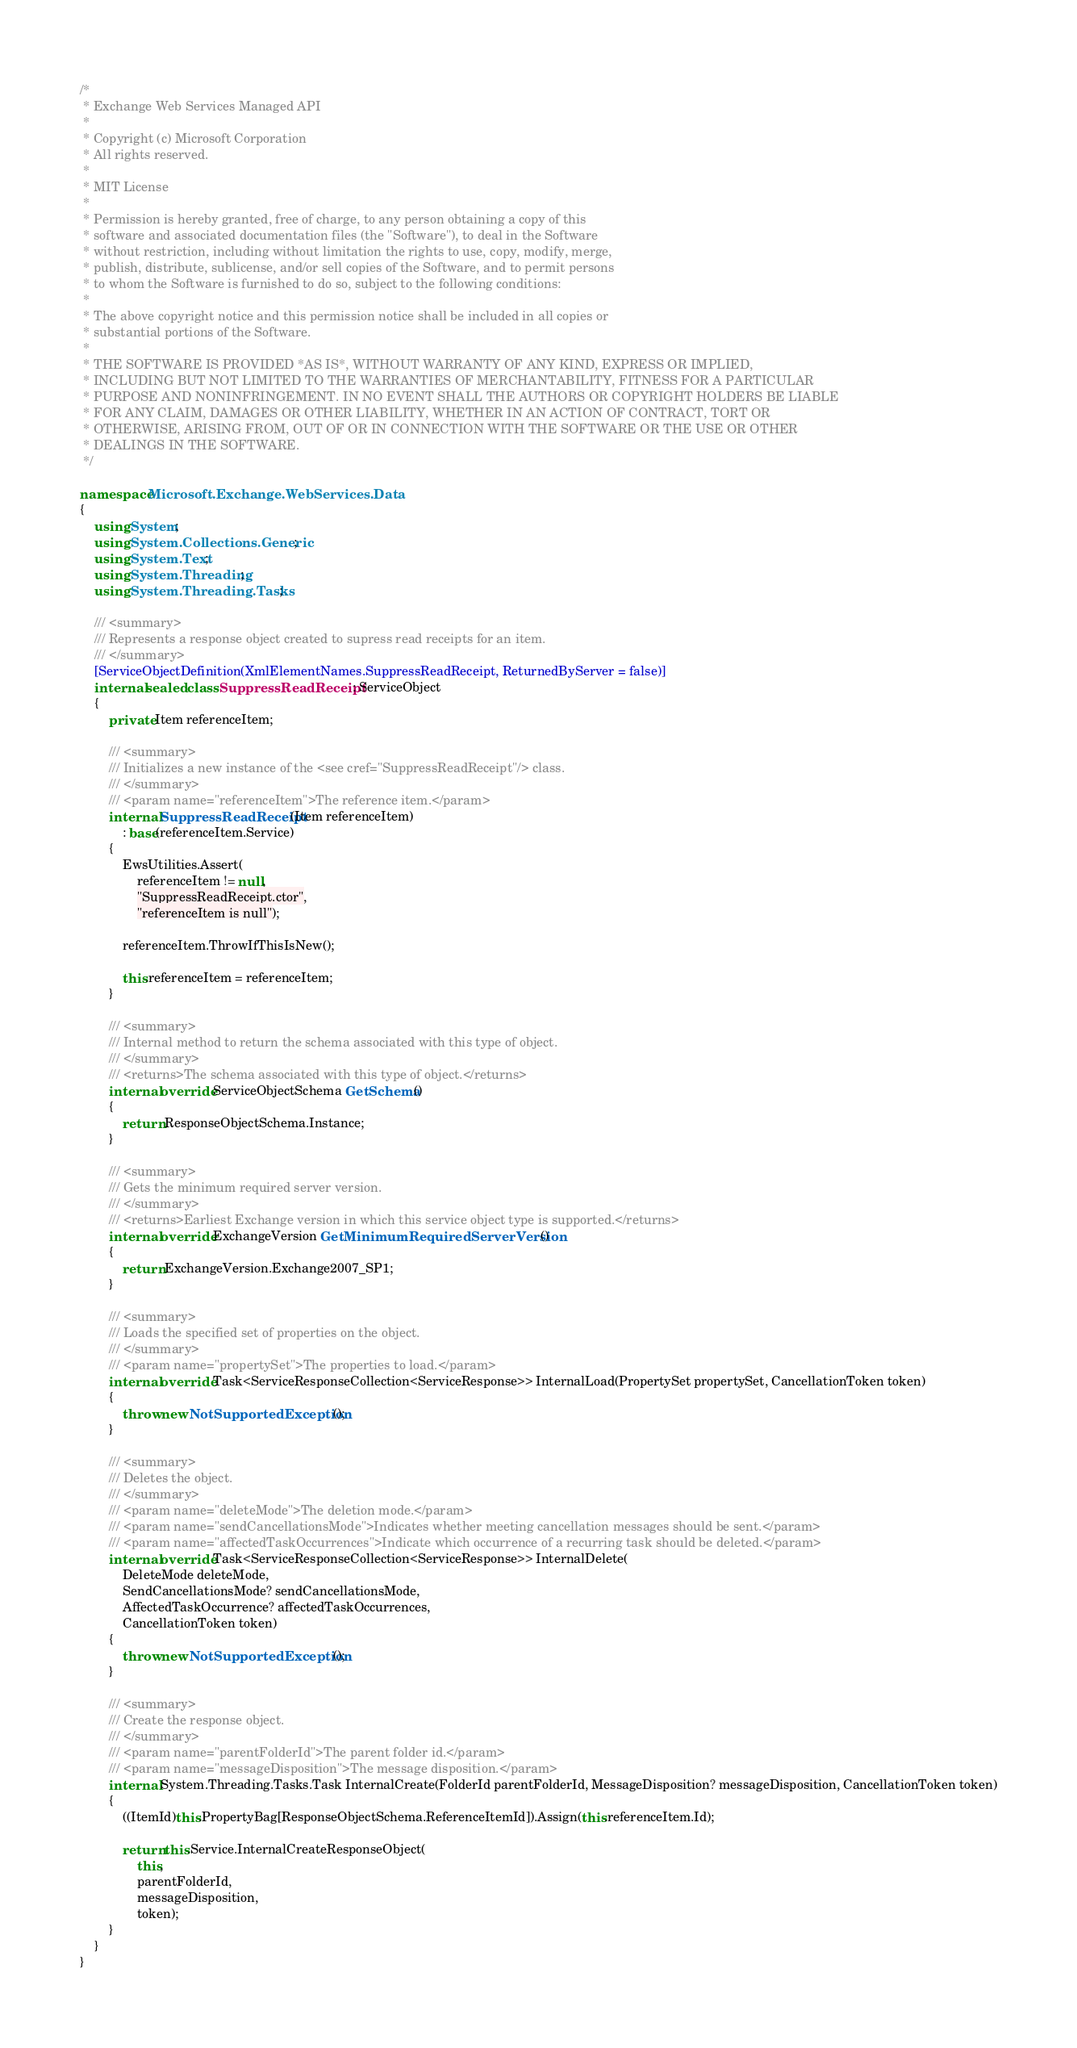<code> <loc_0><loc_0><loc_500><loc_500><_C#_>/*
 * Exchange Web Services Managed API
 *
 * Copyright (c) Microsoft Corporation
 * All rights reserved.
 *
 * MIT License
 *
 * Permission is hereby granted, free of charge, to any person obtaining a copy of this
 * software and associated documentation files (the "Software"), to deal in the Software
 * without restriction, including without limitation the rights to use, copy, modify, merge,
 * publish, distribute, sublicense, and/or sell copies of the Software, and to permit persons
 * to whom the Software is furnished to do so, subject to the following conditions:
 *
 * The above copyright notice and this permission notice shall be included in all copies or
 * substantial portions of the Software.
 *
 * THE SOFTWARE IS PROVIDED *AS IS*, WITHOUT WARRANTY OF ANY KIND, EXPRESS OR IMPLIED,
 * INCLUDING BUT NOT LIMITED TO THE WARRANTIES OF MERCHANTABILITY, FITNESS FOR A PARTICULAR
 * PURPOSE AND NONINFRINGEMENT. IN NO EVENT SHALL THE AUTHORS OR COPYRIGHT HOLDERS BE LIABLE
 * FOR ANY CLAIM, DAMAGES OR OTHER LIABILITY, WHETHER IN AN ACTION OF CONTRACT, TORT OR
 * OTHERWISE, ARISING FROM, OUT OF OR IN CONNECTION WITH THE SOFTWARE OR THE USE OR OTHER
 * DEALINGS IN THE SOFTWARE.
 */

namespace Microsoft.Exchange.WebServices.Data
{
    using System;
    using System.Collections.Generic;
    using System.Text;
    using System.Threading;
    using System.Threading.Tasks;

    /// <summary>
    /// Represents a response object created to supress read receipts for an item.
    /// </summary>
    [ServiceObjectDefinition(XmlElementNames.SuppressReadReceipt, ReturnedByServer = false)]
    internal sealed class SuppressReadReceipt : ServiceObject
    {
        private Item referenceItem;

        /// <summary>
        /// Initializes a new instance of the <see cref="SuppressReadReceipt"/> class.
        /// </summary>
        /// <param name="referenceItem">The reference item.</param>
        internal SuppressReadReceipt(Item referenceItem)
            : base(referenceItem.Service)
        {
            EwsUtilities.Assert(
                referenceItem != null,
                "SuppressReadReceipt.ctor",
                "referenceItem is null");

            referenceItem.ThrowIfThisIsNew();

            this.referenceItem = referenceItem;
        }

        /// <summary>
        /// Internal method to return the schema associated with this type of object.
        /// </summary>
        /// <returns>The schema associated with this type of object.</returns>
        internal override ServiceObjectSchema GetSchema()
        {
            return ResponseObjectSchema.Instance;
        }

        /// <summary>
        /// Gets the minimum required server version.
        /// </summary>
        /// <returns>Earliest Exchange version in which this service object type is supported.</returns>
        internal override ExchangeVersion GetMinimumRequiredServerVersion()
        {
            return ExchangeVersion.Exchange2007_SP1;
        }

        /// <summary>
        /// Loads the specified set of properties on the object.
        /// </summary>
        /// <param name="propertySet">The properties to load.</param>
        internal override Task<ServiceResponseCollection<ServiceResponse>> InternalLoad(PropertySet propertySet, CancellationToken token)
        {
            throw new NotSupportedException();
        }

        /// <summary>
        /// Deletes the object.
        /// </summary>
        /// <param name="deleteMode">The deletion mode.</param>
        /// <param name="sendCancellationsMode">Indicates whether meeting cancellation messages should be sent.</param>
        /// <param name="affectedTaskOccurrences">Indicate which occurrence of a recurring task should be deleted.</param>
        internal override Task<ServiceResponseCollection<ServiceResponse>> InternalDelete(
            DeleteMode deleteMode,
            SendCancellationsMode? sendCancellationsMode,
            AffectedTaskOccurrence? affectedTaskOccurrences,
            CancellationToken token)
        {
            throw new NotSupportedException();
        }

        /// <summary>
        /// Create the response object.
        /// </summary>
        /// <param name="parentFolderId">The parent folder id.</param>
        /// <param name="messageDisposition">The message disposition.</param>
        internal System.Threading.Tasks.Task InternalCreate(FolderId parentFolderId, MessageDisposition? messageDisposition, CancellationToken token)
        {
            ((ItemId)this.PropertyBag[ResponseObjectSchema.ReferenceItemId]).Assign(this.referenceItem.Id);

            return this.Service.InternalCreateResponseObject(
                this,
                parentFolderId,
                messageDisposition,
                token);
        }
    }
}</code> 